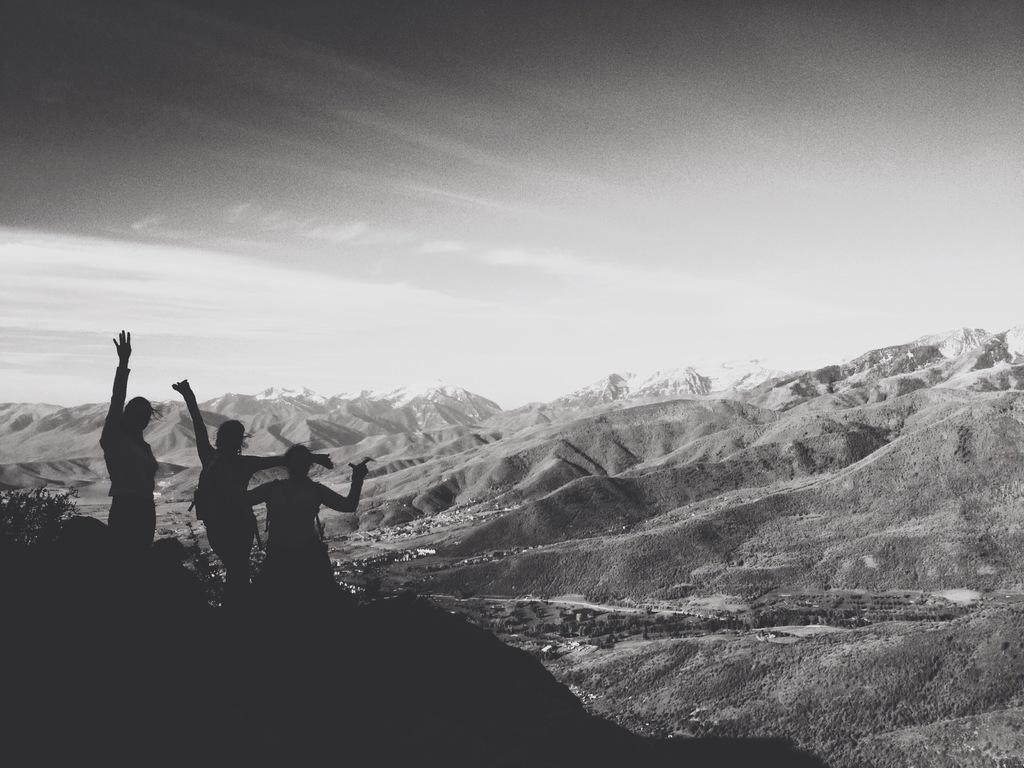What is the color scheme of the image? The image is black and white. Where are the people located in the image? The people are on the left side of the image. How would you describe the lighting on the left side of the image? The view on the left side is dark. What can be seen in the background of the image? There are hills, houses, trees, and the sky visible in the background of the image. How many horses are grazing in the flower field in the image? There are no horses or flower fields present in the image. 